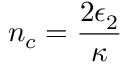Convert formula to latex. <formula><loc_0><loc_0><loc_500><loc_500>n _ { c } = \frac { 2 \epsilon _ { 2 } } { \kappa }</formula> 